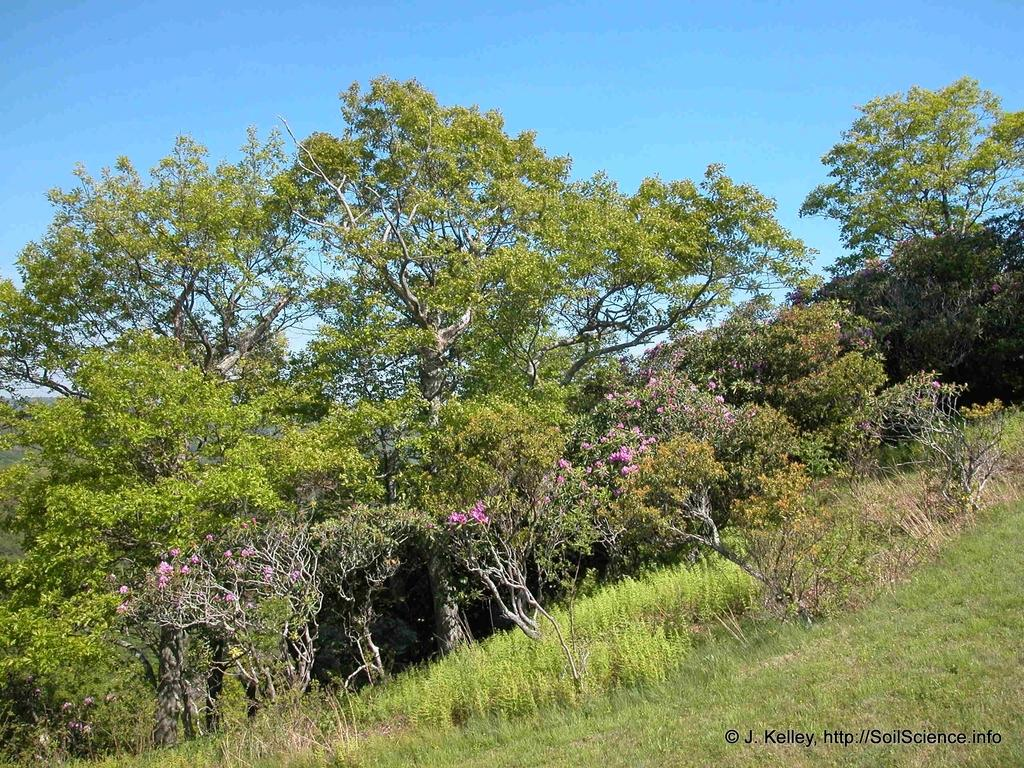What type of vegetation can be seen in the image? There are trees, plants, and grass in the image. What part of the natural environment is visible in the image? The sky is visible in the background of the image. What type of goose can be seen sitting on the sofa in the image? There is no goose or sofa present in the image; it features trees, plants, grass, and the sky. 